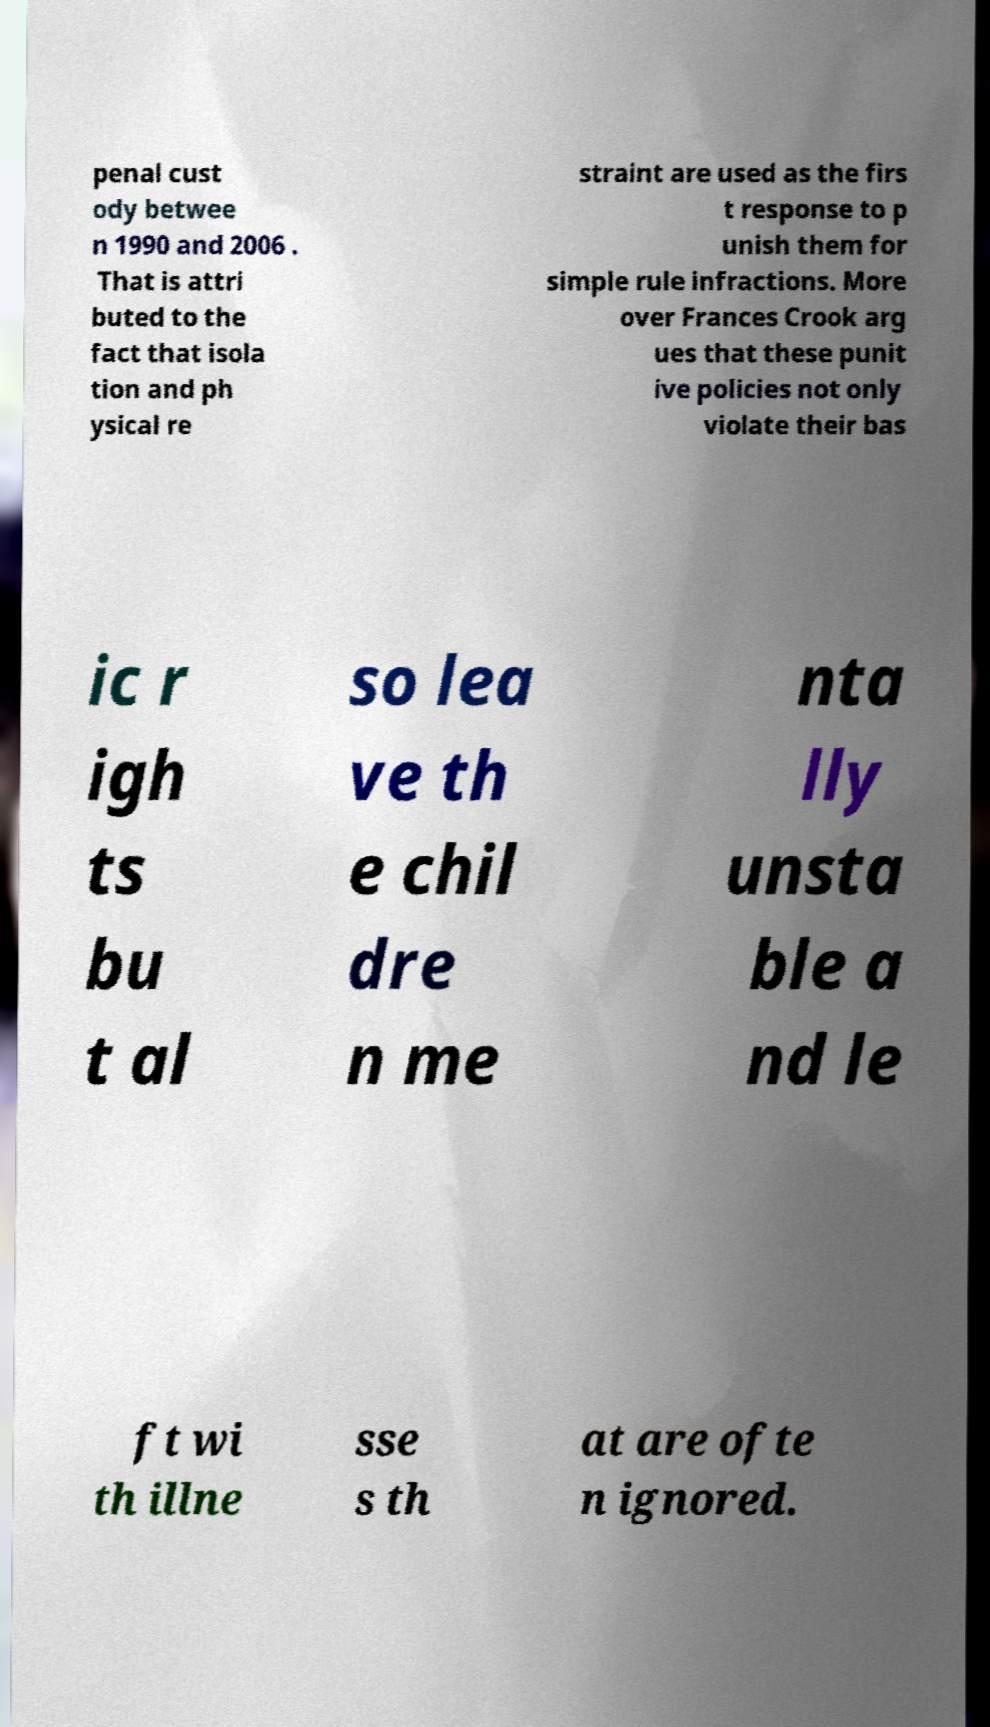Please read and relay the text visible in this image. What does it say? penal cust ody betwee n 1990 and 2006 . That is attri buted to the fact that isola tion and ph ysical re straint are used as the firs t response to p unish them for simple rule infractions. More over Frances Crook arg ues that these punit ive policies not only violate their bas ic r igh ts bu t al so lea ve th e chil dre n me nta lly unsta ble a nd le ft wi th illne sse s th at are ofte n ignored. 